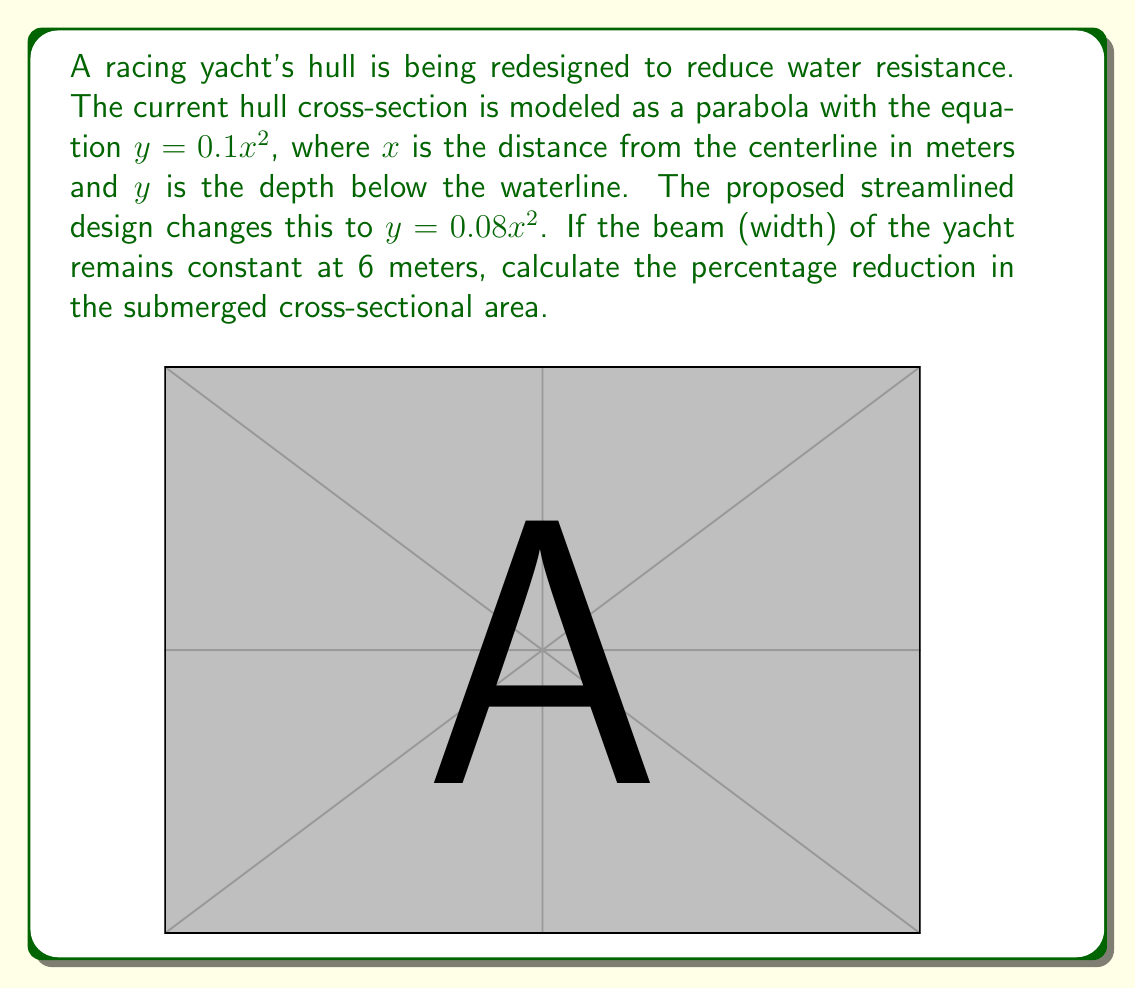Solve this math problem. Let's approach this step-by-step:

1) The cross-sectional area of the hull is represented by the area under the parabola from $x = -3$ to $x = 3$ (since the beam is 6 meters).

2) To find the area, we need to integrate the function from -3 to 3:

   Area = $\int_{-3}^{3} y \, dx$

3) For the original hull: $y = 0.1x^2$
   Area_original = $\int_{-3}^{3} 0.1x^2 \, dx$
                 = $0.1 [\frac{1}{3}x^3]_{-3}^{3}$
                 = $0.1 (\frac{1}{3}(27) - \frac{1}{3}(-27))$
                 = $0.1 (\frac{54}{3})$
                 = $1.8$ square meters

4) For the streamlined hull: $y = 0.08x^2$
   Area_streamlined = $\int_{-3}^{3} 0.08x^2 \, dx$
                    = $0.08 [\frac{1}{3}x^3]_{-3}^{3}$
                    = $0.08 (\frac{1}{3}(27) - \frac{1}{3}(-27))$
                    = $0.08 (\frac{54}{3})$
                    = $1.44$ square meters

5) To calculate the percentage reduction:
   Reduction = $\frac{\text{Area_original} - \text{Area_streamlined}}{\text{Area_original}} \times 100\%$
             = $\frac{1.8 - 1.44}{1.8} \times 100\%$
             = $0.2 \times 100\%$
             = $20\%$

Therefore, the streamlined design reduces the submerged cross-sectional area by 20%.
Answer: 20% 